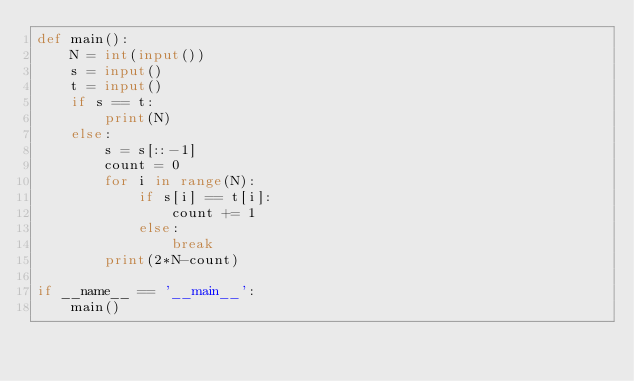Convert code to text. <code><loc_0><loc_0><loc_500><loc_500><_Python_>def main():
    N = int(input())
    s = input()
    t = input()
    if s == t:
        print(N)
    else:
        s = s[::-1]
        count = 0
        for i in range(N):
            if s[i] == t[i]:
                count += 1
            else:
                break
        print(2*N-count)

if __name__ == '__main__':
    main()</code> 